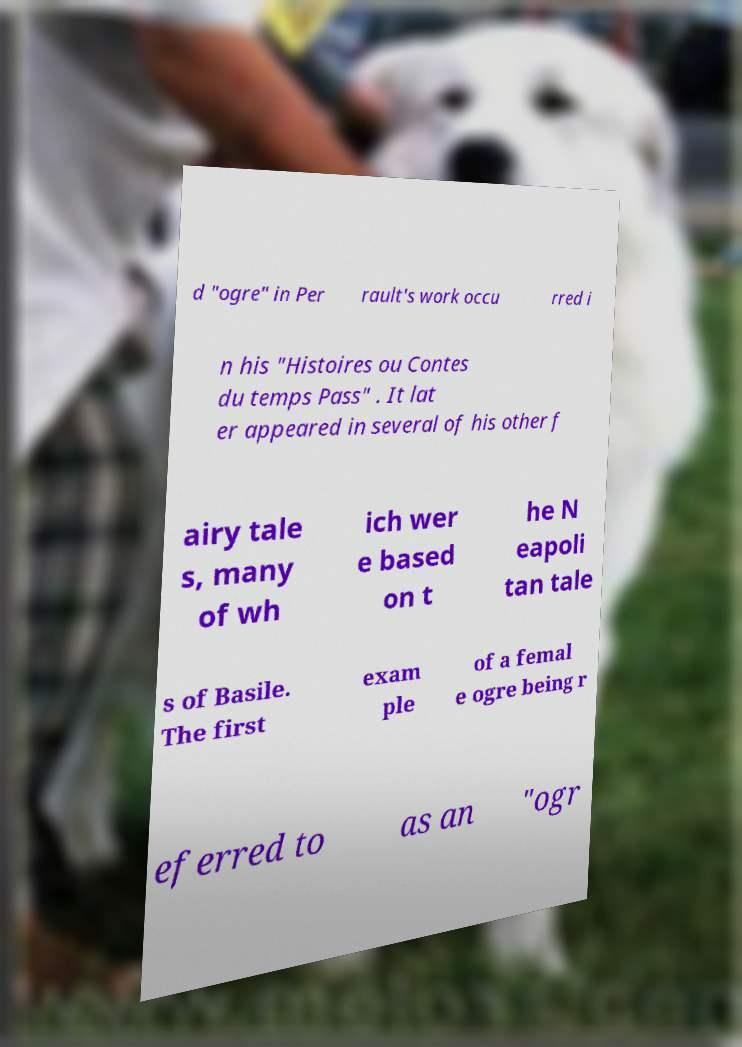What messages or text are displayed in this image? I need them in a readable, typed format. d "ogre" in Per rault's work occu rred i n his "Histoires ou Contes du temps Pass" . It lat er appeared in several of his other f airy tale s, many of wh ich wer e based on t he N eapoli tan tale s of Basile. The first exam ple of a femal e ogre being r eferred to as an "ogr 